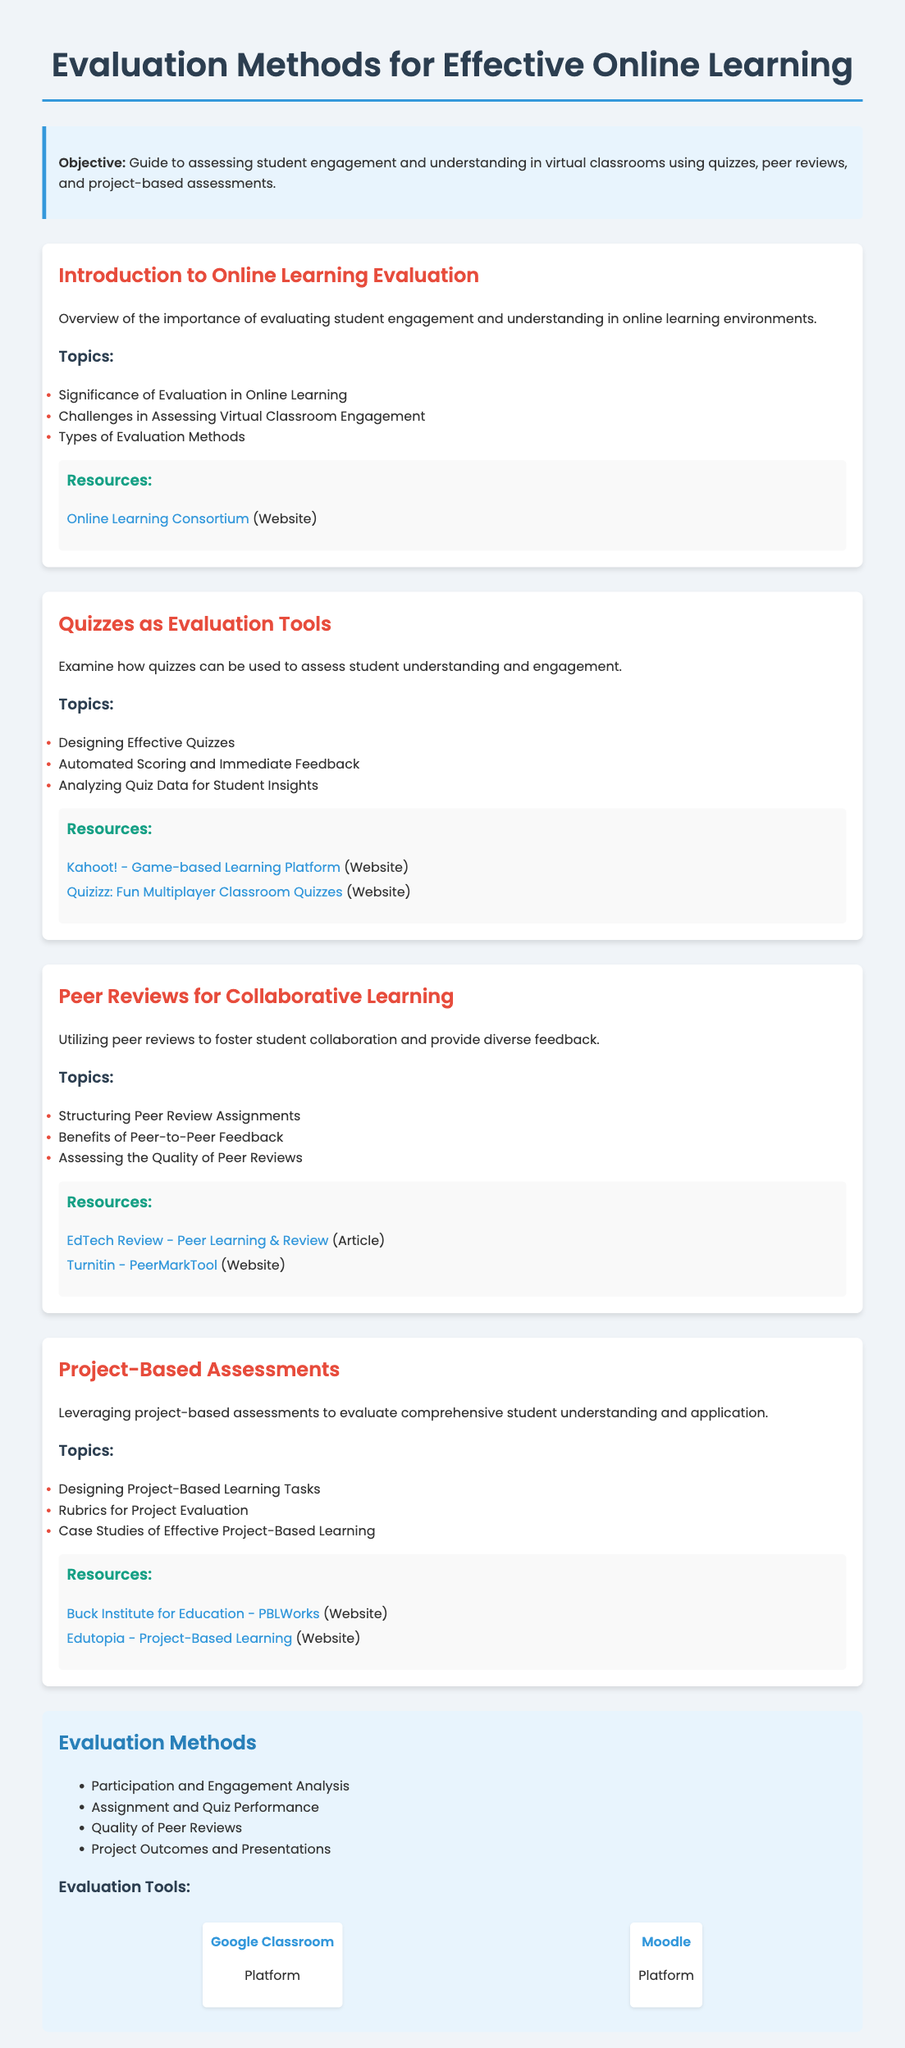What is the title of the syllabus? The title is the main heading of the document, which is typically the subject of the course.
Answer: Evaluation Methods for Effective Online Learning What method focuses on student collaboration? This method promotes peer interaction and diverse feedback among students.
Answer: Peer Reviews What is the first major topic covered in the module about quizzes? The first topic is typically the foundation of understanding in the specific module.
Answer: Designing Effective Quizzes How many resources are listed under Project-Based Assessments? The resources are supplementary materials provided to enhance learning and understanding of the topic.
Answer: Two What evaluation method includes presentation quality? This method assesses a student's practical application of their knowledge in a project format.
Answer: Project Outcomes and Presentations Which platform is mentioned for classroom management? This platform is a popular tool used for managing online classes and assignments.
Answer: Google Classroom What is highlighted as a significant challenge in online learning evaluations? This challenge is related to understanding student participation and engagement in a virtual setting.
Answer: Assessing Virtual Classroom Engagement What type of assessments does the syllabus emphasize alongside quizzes and peer reviews? The focus here is on assessments that require students to apply knowledge in a practical context.
Answer: Project-Based Assessments What color is used for the module headings? The color is a specific hue chosen for consistency and visual appeal throughout the document's modules.
Answer: Red 